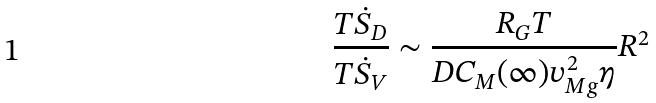<formula> <loc_0><loc_0><loc_500><loc_500>\frac { T \dot { S } _ { D } } { T \dot { S } _ { V } } \sim \frac { R _ { G } T } { D C _ { M } ( \infty ) v _ { M g } ^ { 2 } \eta } R ^ { 2 }</formula> 